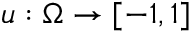<formula> <loc_0><loc_0><loc_500><loc_500>u \colon \Omega \to [ - 1 , 1 ]</formula> 